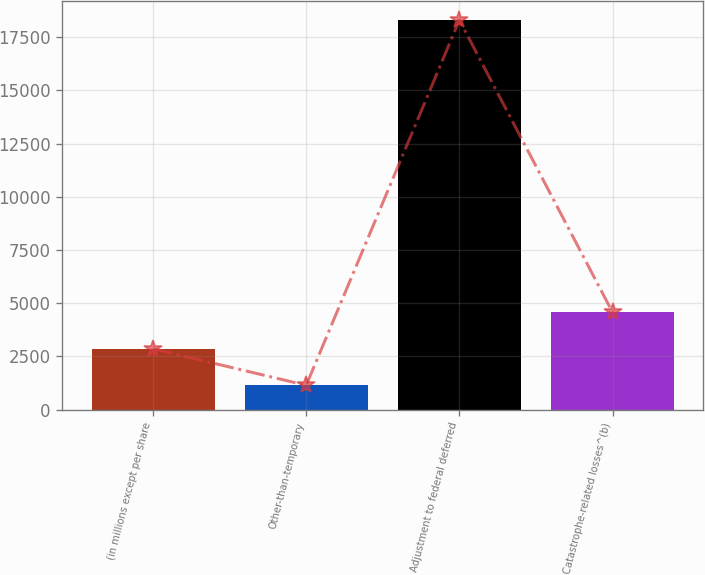Convert chart to OTSL. <chart><loc_0><loc_0><loc_500><loc_500><bar_chart><fcel>(in millions except per share<fcel>Other-than-temporary<fcel>Adjustment to federal deferred<fcel>Catastrophe-related losses^(b)<nl><fcel>2858.5<fcel>1142<fcel>18307<fcel>4575<nl></chart> 